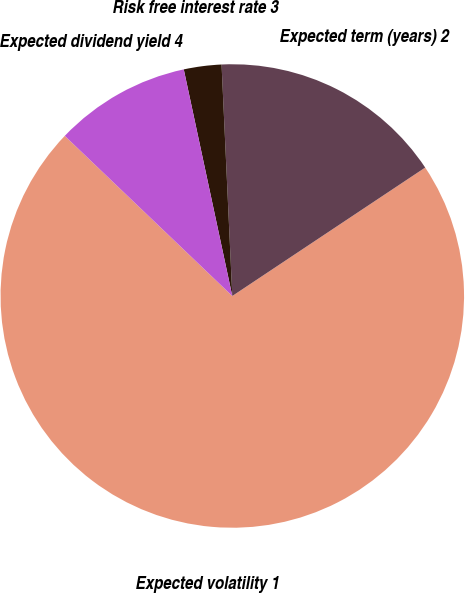Convert chart to OTSL. <chart><loc_0><loc_0><loc_500><loc_500><pie_chart><fcel>Expected volatility 1<fcel>Expected term (years) 2<fcel>Risk free interest rate 3<fcel>Expected dividend yield 4<nl><fcel>71.49%<fcel>16.39%<fcel>2.62%<fcel>9.5%<nl></chart> 